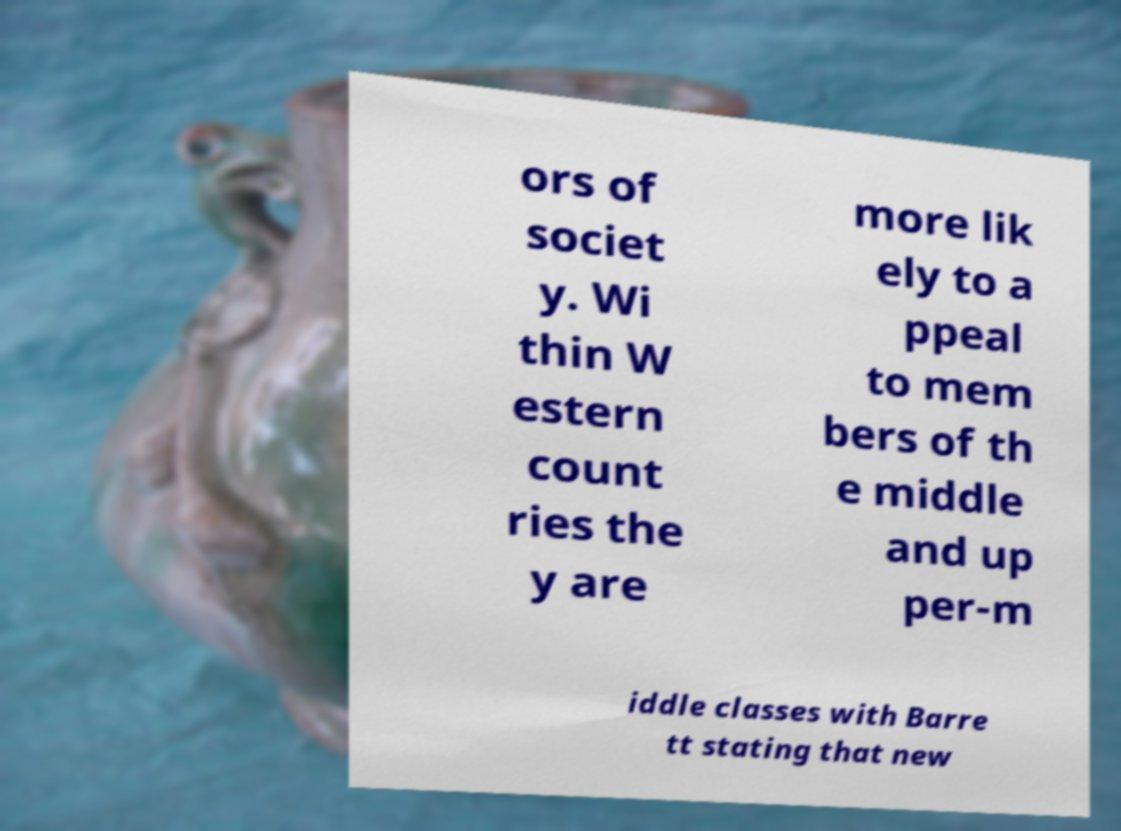Could you assist in decoding the text presented in this image and type it out clearly? ors of societ y. Wi thin W estern count ries the y are more lik ely to a ppeal to mem bers of th e middle and up per-m iddle classes with Barre tt stating that new 